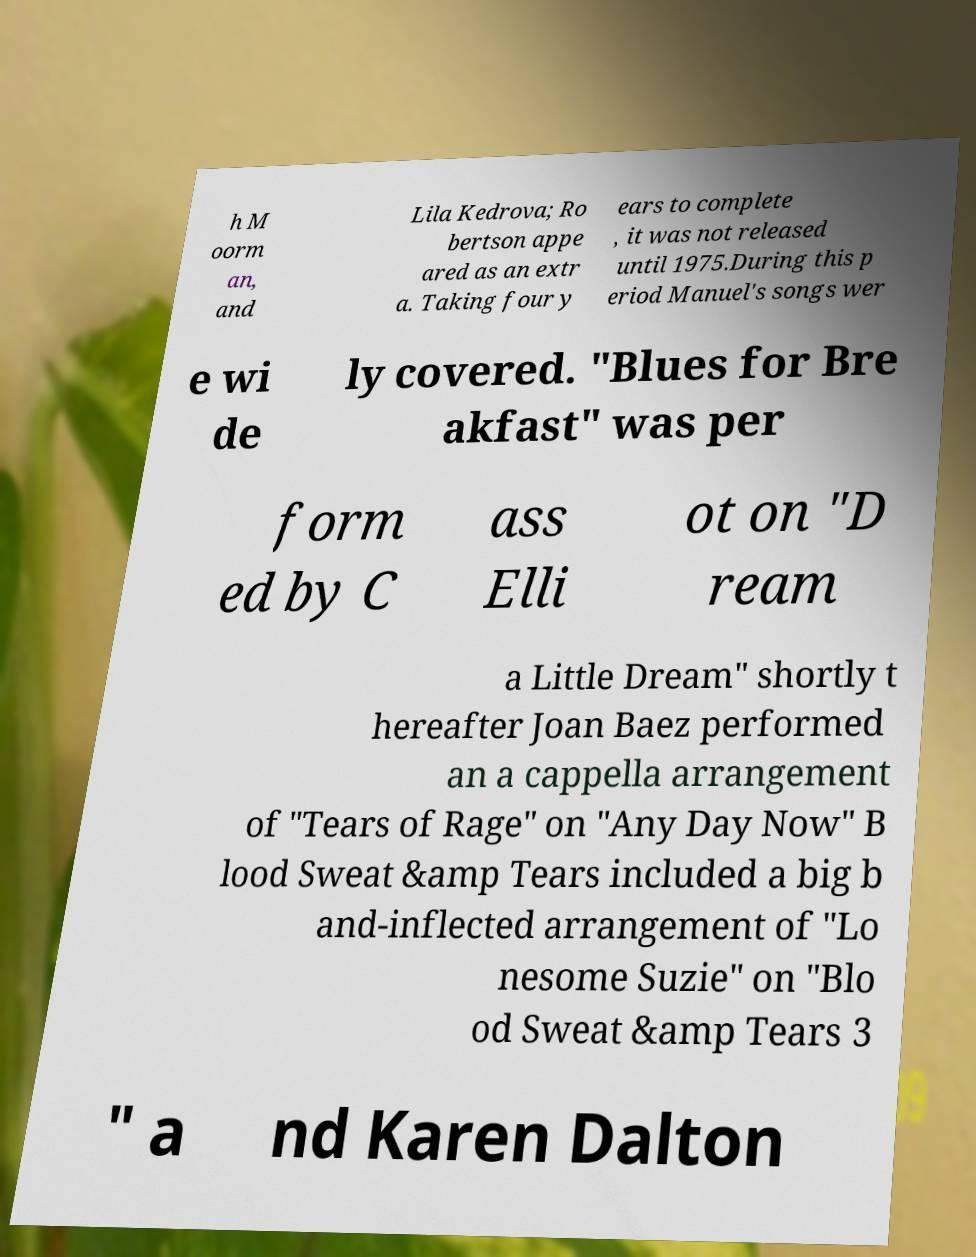Please read and relay the text visible in this image. What does it say? h M oorm an, and Lila Kedrova; Ro bertson appe ared as an extr a. Taking four y ears to complete , it was not released until 1975.During this p eriod Manuel's songs wer e wi de ly covered. "Blues for Bre akfast" was per form ed by C ass Elli ot on "D ream a Little Dream" shortly t hereafter Joan Baez performed an a cappella arrangement of "Tears of Rage" on "Any Day Now" B lood Sweat &amp Tears included a big b and-inflected arrangement of "Lo nesome Suzie" on "Blo od Sweat &amp Tears 3 " a nd Karen Dalton 